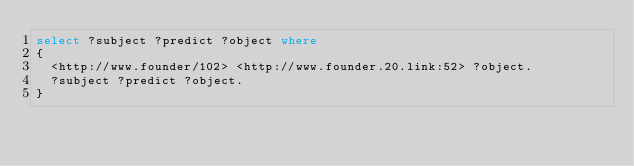Convert code to text. <code><loc_0><loc_0><loc_500><loc_500><_SQL_>select ?subject ?predict ?object where 
{
	<http://www.founder/102> <http://www.founder.20.link:52> ?object.  
	?subject ?predict ?object.
}
</code> 